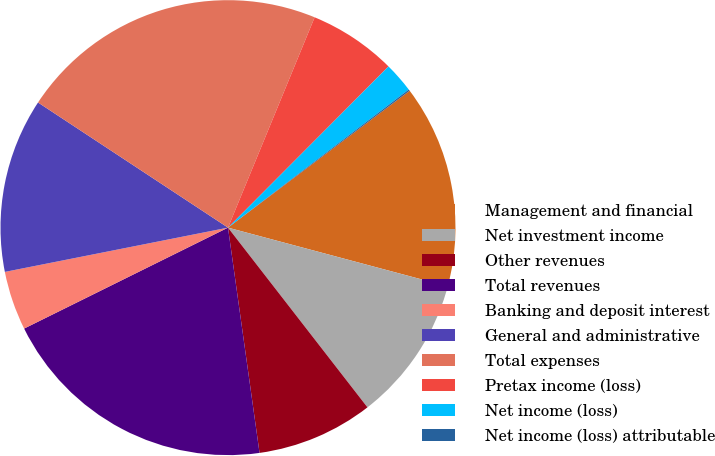<chart> <loc_0><loc_0><loc_500><loc_500><pie_chart><fcel>Management and financial<fcel>Net investment income<fcel>Other revenues<fcel>Total revenues<fcel>Banking and deposit interest<fcel>General and administrative<fcel>Total expenses<fcel>Pretax income (loss)<fcel>Net income (loss)<fcel>Net income (loss) attributable<nl><fcel>14.44%<fcel>10.34%<fcel>8.29%<fcel>19.9%<fcel>4.2%<fcel>12.39%<fcel>21.95%<fcel>6.25%<fcel>2.15%<fcel>0.1%<nl></chart> 